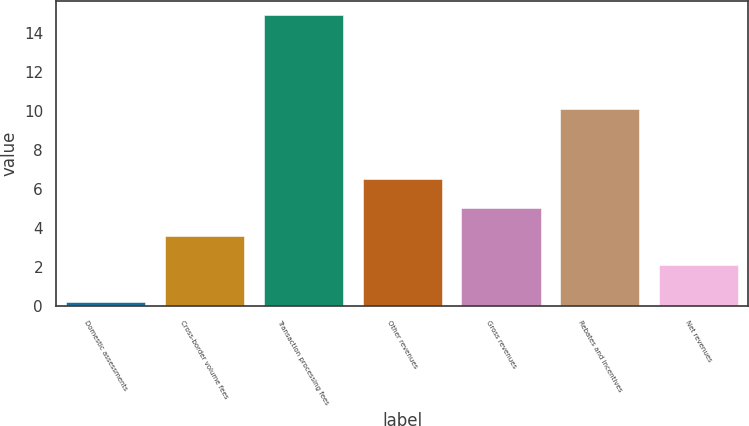Convert chart to OTSL. <chart><loc_0><loc_0><loc_500><loc_500><bar_chart><fcel>Domestic assessments<fcel>Cross-border volume fees<fcel>Transaction processing fees<fcel>Other revenues<fcel>Gross revenues<fcel>Rebates and incentives<fcel>Net revenues<nl><fcel>0.2<fcel>3.57<fcel>14.9<fcel>6.51<fcel>5.04<fcel>10.1<fcel>2.1<nl></chart> 